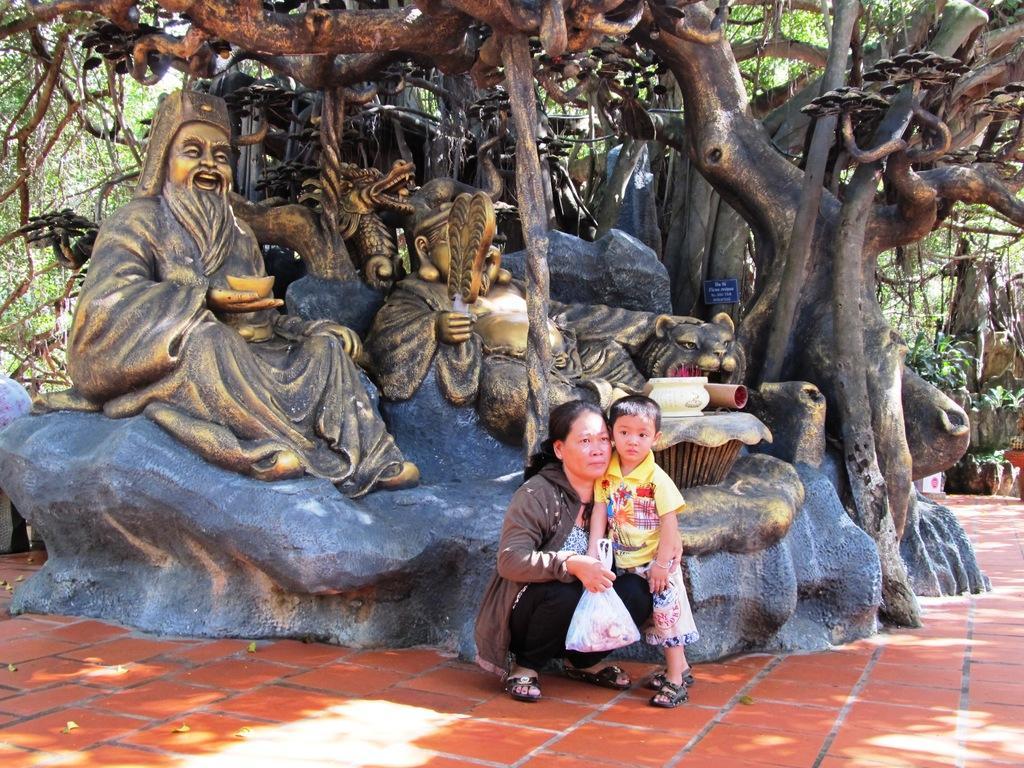Could you give a brief overview of what you see in this image? In this picture we can see a woman, boy on the ground, woman is holding a polythene cover, here we can see statues, rocks, name board and some objects and in the background we can see trees. 